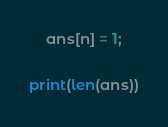Convert code to text. <code><loc_0><loc_0><loc_500><loc_500><_Python_>    ans[n] = 1;

print(len(ans))</code> 